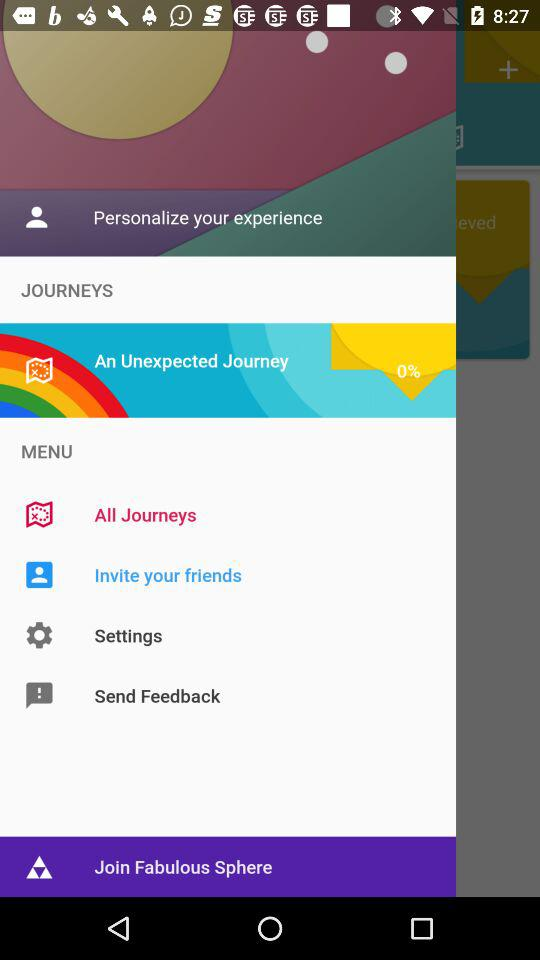How many percent of the journey is complete?
Answer the question using a single word or phrase. 0% 